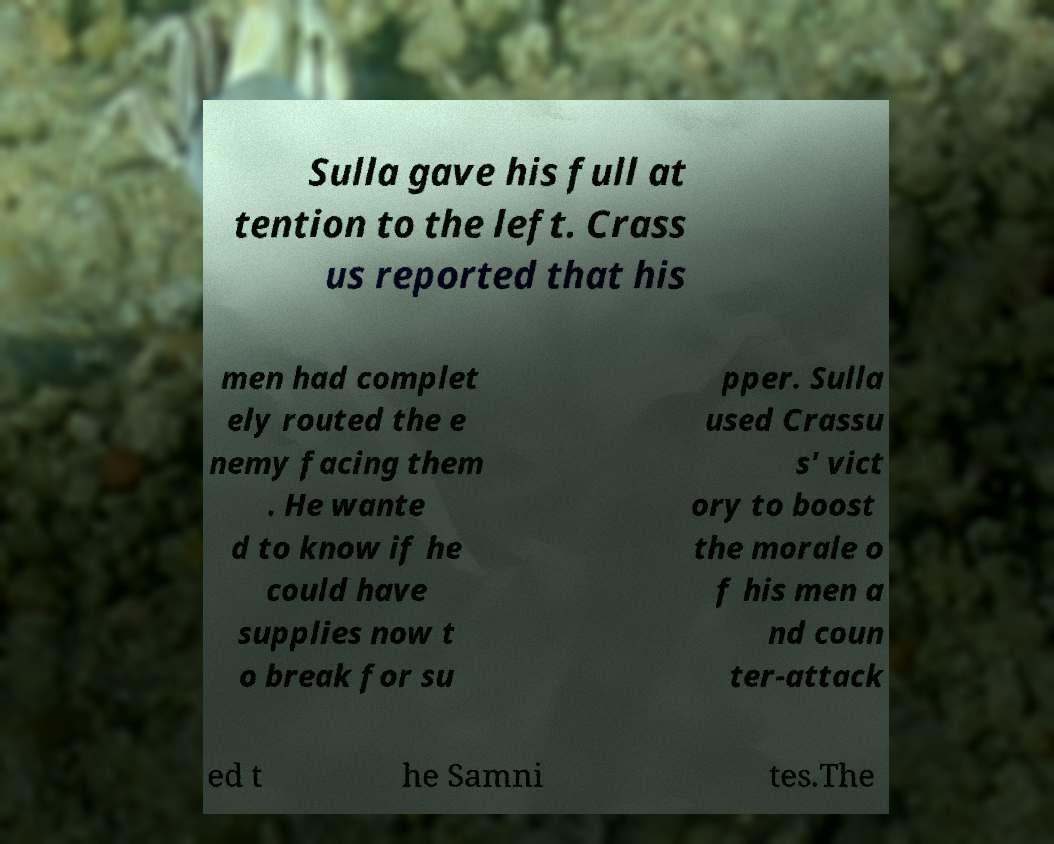For documentation purposes, I need the text within this image transcribed. Could you provide that? Sulla gave his full at tention to the left. Crass us reported that his men had complet ely routed the e nemy facing them . He wante d to know if he could have supplies now t o break for su pper. Sulla used Crassu s' vict ory to boost the morale o f his men a nd coun ter-attack ed t he Samni tes.The 